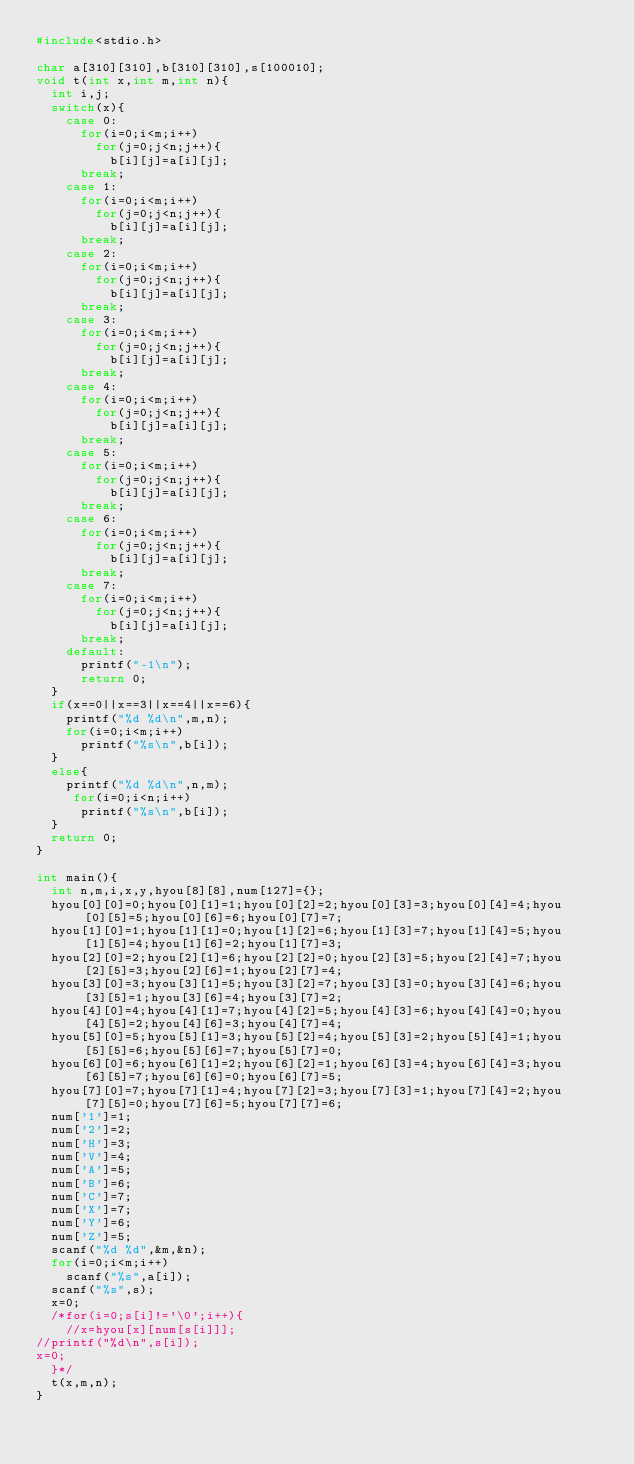<code> <loc_0><loc_0><loc_500><loc_500><_C_>#include<stdio.h>

char a[310][310],b[310][310],s[100010];
void t(int x,int m,int n){
  int i,j;
  switch(x){
    case 0:
      for(i=0;i<m;i++)
        for(j=0;j<n;j++){
          b[i][j]=a[i][j];
      break;
    case 1:
      for(i=0;i<m;i++)
        for(j=0;j<n;j++){
          b[i][j]=a[i][j];
      break;
    case 2:
      for(i=0;i<m;i++)
        for(j=0;j<n;j++){
          b[i][j]=a[i][j];
      break;
    case 3:
      for(i=0;i<m;i++)
        for(j=0;j<n;j++){
          b[i][j]=a[i][j];
      break;
    case 4:
      for(i=0;i<m;i++)
        for(j=0;j<n;j++){
          b[i][j]=a[i][j];
      break;
    case 5:
      for(i=0;i<m;i++)
        for(j=0;j<n;j++){
          b[i][j]=a[i][j];
      break;
    case 6:
      for(i=0;i<m;i++)
        for(j=0;j<n;j++){
          b[i][j]=a[i][j];
      break;
    case 7:
      for(i=0;i<m;i++)
        for(j=0;j<n;j++){
          b[i][j]=a[i][j];
      break;
    default:
      printf("-1\n");
      return 0;
  }
  if(x==0||x==3||x==4||x==6){
    printf("%d %d\n",m,n);
    for(i=0;i<m;i++)
      printf("%s\n",b[i]);
  }
  else{
    printf("%d %d\n",n,m);
     for(i=0;i<n;i++)
      printf("%s\n",b[i]);
  }
  return 0;
}

int main(){
  int n,m,i,x,y,hyou[8][8],num[127]={};
  hyou[0][0]=0;hyou[0][1]=1;hyou[0][2]=2;hyou[0][3]=3;hyou[0][4]=4;hyou[0][5]=5;hyou[0][6]=6;hyou[0][7]=7;
  hyou[1][0]=1;hyou[1][1]=0;hyou[1][2]=6;hyou[1][3]=7;hyou[1][4]=5;hyou[1][5]=4;hyou[1][6]=2;hyou[1][7]=3;
  hyou[2][0]=2;hyou[2][1]=6;hyou[2][2]=0;hyou[2][3]=5;hyou[2][4]=7;hyou[2][5]=3;hyou[2][6]=1;hyou[2][7]=4;
  hyou[3][0]=3;hyou[3][1]=5;hyou[3][2]=7;hyou[3][3]=0;hyou[3][4]=6;hyou[3][5]=1;hyou[3][6]=4;hyou[3][7]=2;
  hyou[4][0]=4;hyou[4][1]=7;hyou[4][2]=5;hyou[4][3]=6;hyou[4][4]=0;hyou[4][5]=2;hyou[4][6]=3;hyou[4][7]=4;
  hyou[5][0]=5;hyou[5][1]=3;hyou[5][2]=4;hyou[5][3]=2;hyou[5][4]=1;hyou[5][5]=6;hyou[5][6]=7;hyou[5][7]=0;
  hyou[6][0]=6;hyou[6][1]=2;hyou[6][2]=1;hyou[6][3]=4;hyou[6][4]=3;hyou[6][5]=7;hyou[6][6]=0;hyou[6][7]=5;
  hyou[7][0]=7;hyou[7][1]=4;hyou[7][2]=3;hyou[7][3]=1;hyou[7][4]=2;hyou[7][5]=0;hyou[7][6]=5;hyou[7][7]=6;
  num['1']=1;
  num['2']=2;
  num['H']=3;
  num['V']=4;
  num['A']=5;
  num['B']=6;
  num['C']=7;
  num['X']=7;
  num['Y']=6;
  num['Z']=5;
  scanf("%d %d",&m,&n);
  for(i=0;i<m;i++)
    scanf("%s",a[i]);
  scanf("%s",s);
  x=0;
  /*for(i=0;s[i]!='\0';i++){
    //x=hyou[x][num[s[i]]];
//printf("%d\n",s[i]);
x=0;
  }*/
  t(x,m,n);
}</code> 